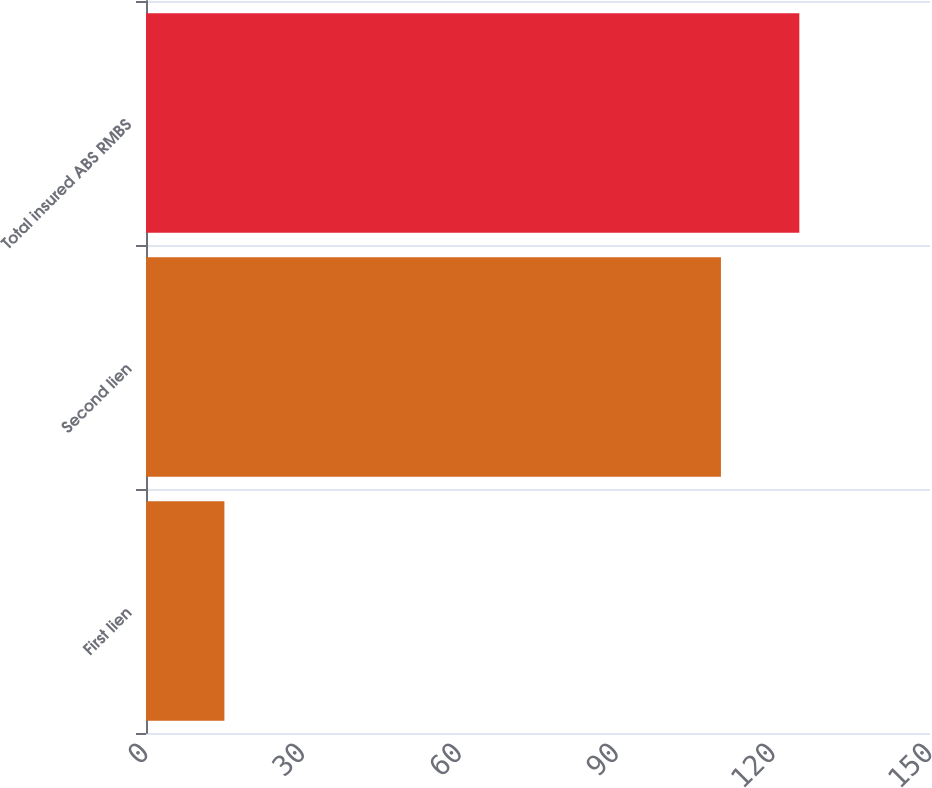<chart> <loc_0><loc_0><loc_500><loc_500><bar_chart><fcel>First lien<fcel>Second lien<fcel>Total insured ABS RMBS<nl><fcel>15<fcel>110<fcel>125<nl></chart> 